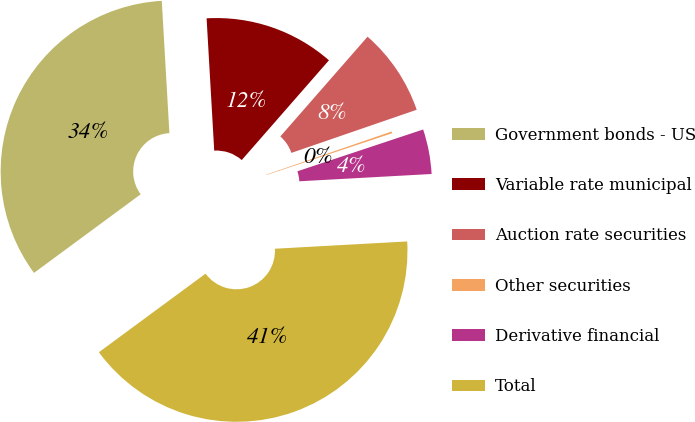Convert chart. <chart><loc_0><loc_0><loc_500><loc_500><pie_chart><fcel>Government bonds - US<fcel>Variable rate municipal<fcel>Auction rate securities<fcel>Other securities<fcel>Derivative financial<fcel>Total<nl><fcel>34.19%<fcel>12.35%<fcel>8.29%<fcel>0.17%<fcel>4.23%<fcel>40.77%<nl></chart> 